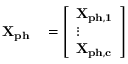<formula> <loc_0><loc_0><loc_500><loc_500>\begin{array} { r l } { X _ { p h } } & = \left [ \begin{array} { l } { X _ { p h , 1 } } \\ { \vdots } \\ { X _ { p h , c } } \end{array} \right ] } \end{array}</formula> 